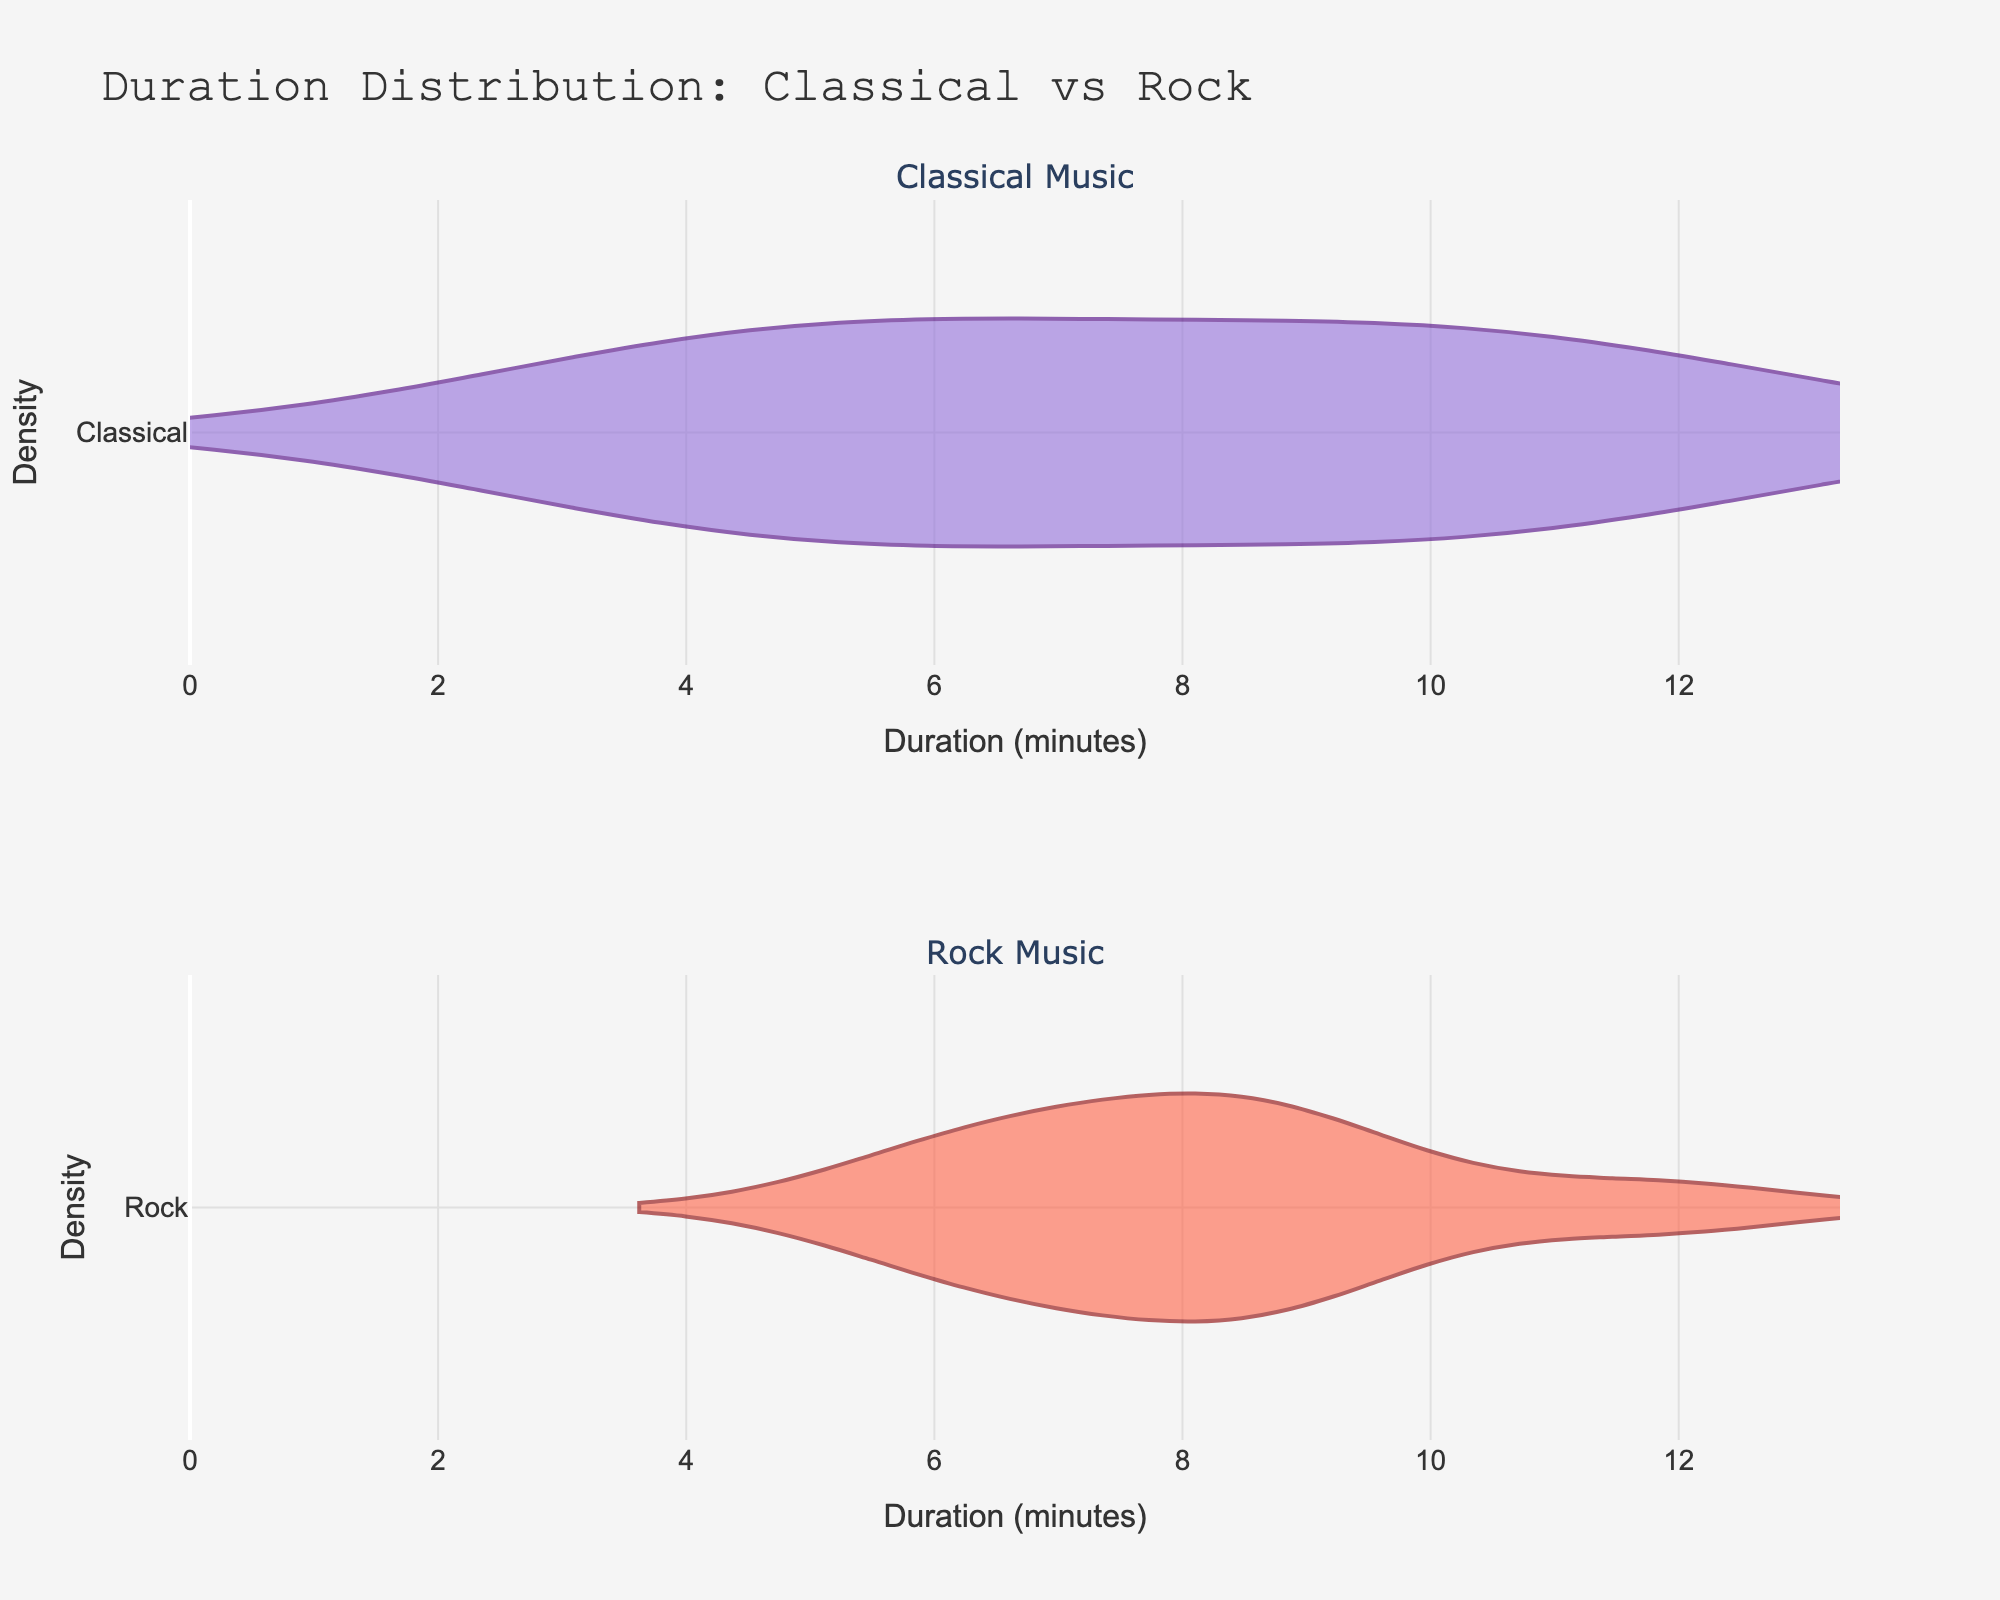What is the title of the plot? The title of a plot is usually displayed at the top of the figure. In this case, the title is "Duration Distribution: Classical vs Rock" which clearly describes what the figure is about.
Answer: Duration Distribution: Classical vs Rock What do the x-axes represent? The labels on the x-axes usually describe what variable is being measured. Here, both x-axes are labeled "Duration (minutes)", indicating that they represent the duration of the music pieces in minutes.
Answer: Duration (minutes) Which axes display densities in the figure? The y-axes usually show densities in such plots. Here, both y-axes of the subplots are labeled "Density".
Answer: y-axes How many subplots are there, and what genres do they represent? The figure contains 2 subplots, each representing a different genre of music. According to the subplot titles, the top one represents "Classical Music" and the bottom one represents "Rock Music".
Answer: 2 subplots; "Classical Music" and "Rock Music" Which genre shows a wider spread in music duration? By observing the width of the distributions in both subplots, we notice that the spread of durations in each subplot indicates the variation. The "Rock Music" subplot has a wider spread compared to "Classical Music".
Answer: Rock Music What is the range of duration for classical music and rock music? To determine the range, look at the minimum and maximum values on the x-axes. For classical music, the range is from around 3.2 to 12.3 minutes. For rock music, the range is from around 5.9 to 11.8 minutes.
Answer: Classical: 3.2 to 12.3 minutes; Rock: 5.9 to 11.8 minutes Which genre has the piece with the longest duration? By comparing the maximum values in both subplots, we can see that for classical music, the longest piece is 12.3 minutes, whereas for rock music, the longest piece is 11.8 minutes. Hence, the longest duration is in classical music.
Answer: Classical Music What's the approximate median duration of classical music? The median divides the dataset into two equal halves. Observing the violin plot for classical music, the median seems to be around the middle of the interquartile range, approximately between 8 to 9 minutes.
Answer: Approximately 8.7 minutes Which genre generally has shorter pieces? By comparing the densities and spread of the durations in both subplots, it appears that classical music generally has shorter pieces than rock music. The density of classical music is higher in the lower duration range.
Answer: Classical Music 